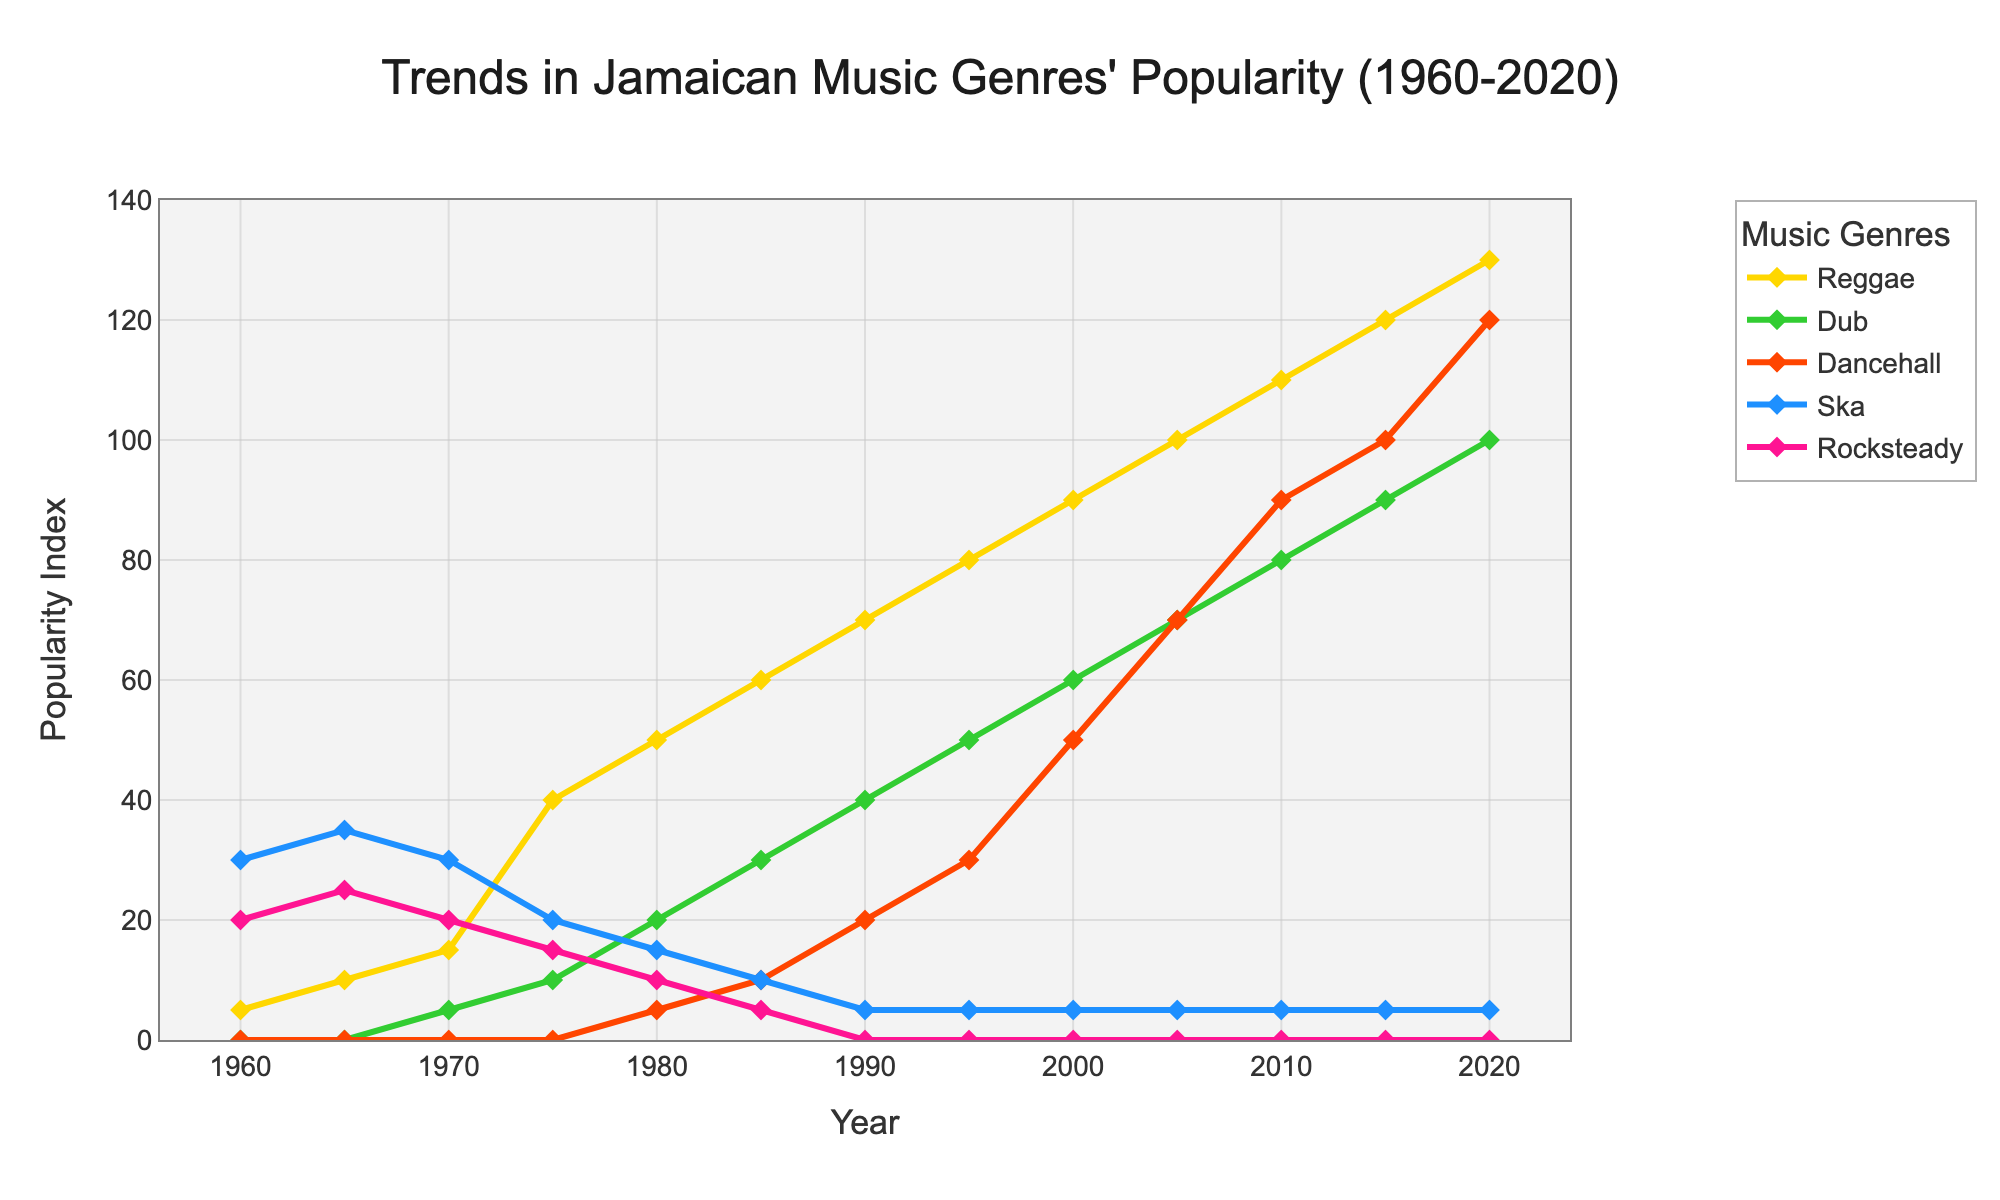What's the title of the figure? The title is usually positioned at the top of the figure and serves as a description of the overall content. In this case, the title of the figure is clearly displayed.
Answer: Trends in Jamaican Music Genres' Popularity (1960-2020) What is the popularity index of Dancehall music in 1990? Observe the Dancehall line on the graph and locate the year 1990 on the x-axis, then find the corresponding value on the y-axis. The index at that point is 20.
Answer: 20 Which genre had the highest popularity index in 1985? Look at the data points for all the genres in 1985. Compare the y-axis values. Reggae has the highest popularity index among the listed genres.
Answer: Reggae Between what years did Dub music start showing a steady increase in popularity? To identify this, examine the trajectory of the Dub line. It starts showing a steady increase from 1970 (with an index of 5) and continues without a decrease.
Answer: 1970-2020 How did Ska's popularity change over the analyzed period? To understand Ska's trend, observe its line from 1960 to 2020. It starts high, slightly rises, and then gradually decreases to a constant minimal value.
Answer: Decreased In what year did the popularity index of Rocksteady drop to zero? To find this, trace the Rocksteady line and determine the year when it reaches the y-axis value of 0. This happened in 1990.
Answer: 1990 What is the difference in popularity index between Reggae and Dub music in 2010? Look at the y-axis values for both Reggae and Dub in 2010. Subtract Dub's index (80) from Reggae's index (110). The difference is 30.
Answer: 30 Which genre had the largest increase in popularity from 1960 to 2000? Calculate the difference in popularity for each genre between 1960 and 2000. Reggae increases from 5 to 90, which is the largest increase (85).
Answer: Reggae Between Reggae and Dancehall, which genre's popularity rose more sharply between 2005 and 2015? Examine the slopes of the lines for Reggae and Dancehall between 2005 and 2015. Dancehall increases by 30, while Reggae increases by 20. Thus, Dancehall's rise is sharper.
Answer: Dancehall 